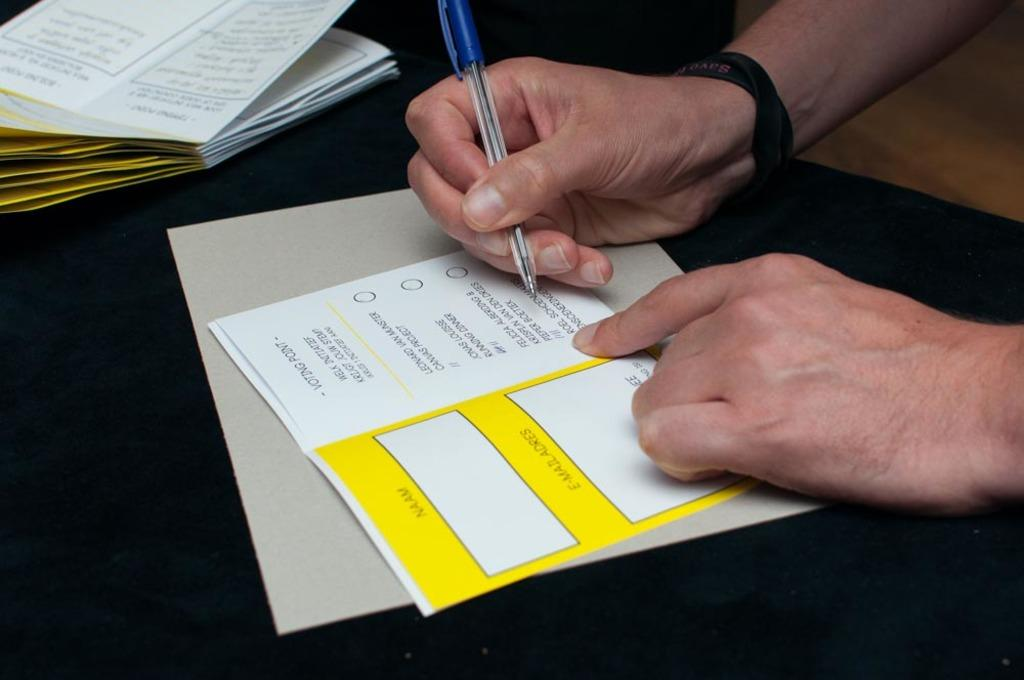<image>
Create a compact narrative representing the image presented. A person is filling out a card that says voting point at the top. 